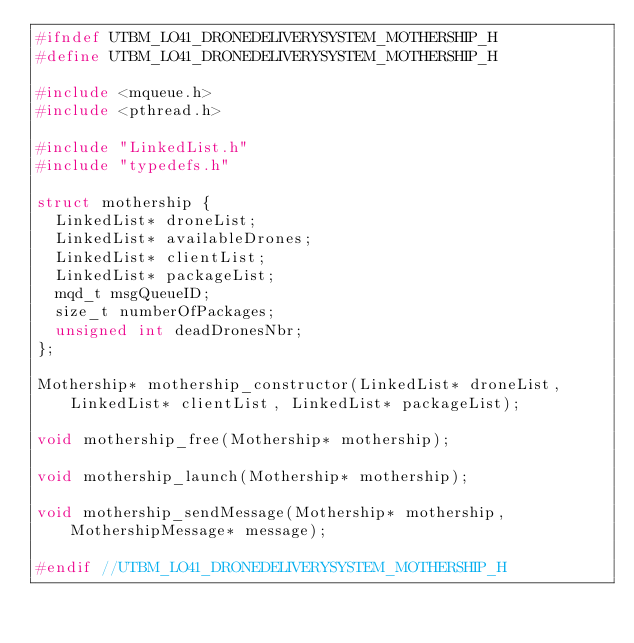<code> <loc_0><loc_0><loc_500><loc_500><_C_>#ifndef UTBM_LO41_DRONEDELIVERYSYSTEM_MOTHERSHIP_H
#define UTBM_LO41_DRONEDELIVERYSYSTEM_MOTHERSHIP_H

#include <mqueue.h>
#include <pthread.h>

#include "LinkedList.h"
#include "typedefs.h"

struct mothership {
	LinkedList* droneList;
	LinkedList* availableDrones;
	LinkedList* clientList;
	LinkedList* packageList;
	mqd_t msgQueueID;
	size_t numberOfPackages;
	unsigned int deadDronesNbr;
};

Mothership* mothership_constructor(LinkedList* droneList, LinkedList* clientList, LinkedList* packageList);

void mothership_free(Mothership* mothership);

void mothership_launch(Mothership* mothership);

void mothership_sendMessage(Mothership* mothership, MothershipMessage* message);

#endif //UTBM_LO41_DRONEDELIVERYSYSTEM_MOTHERSHIP_H
</code> 